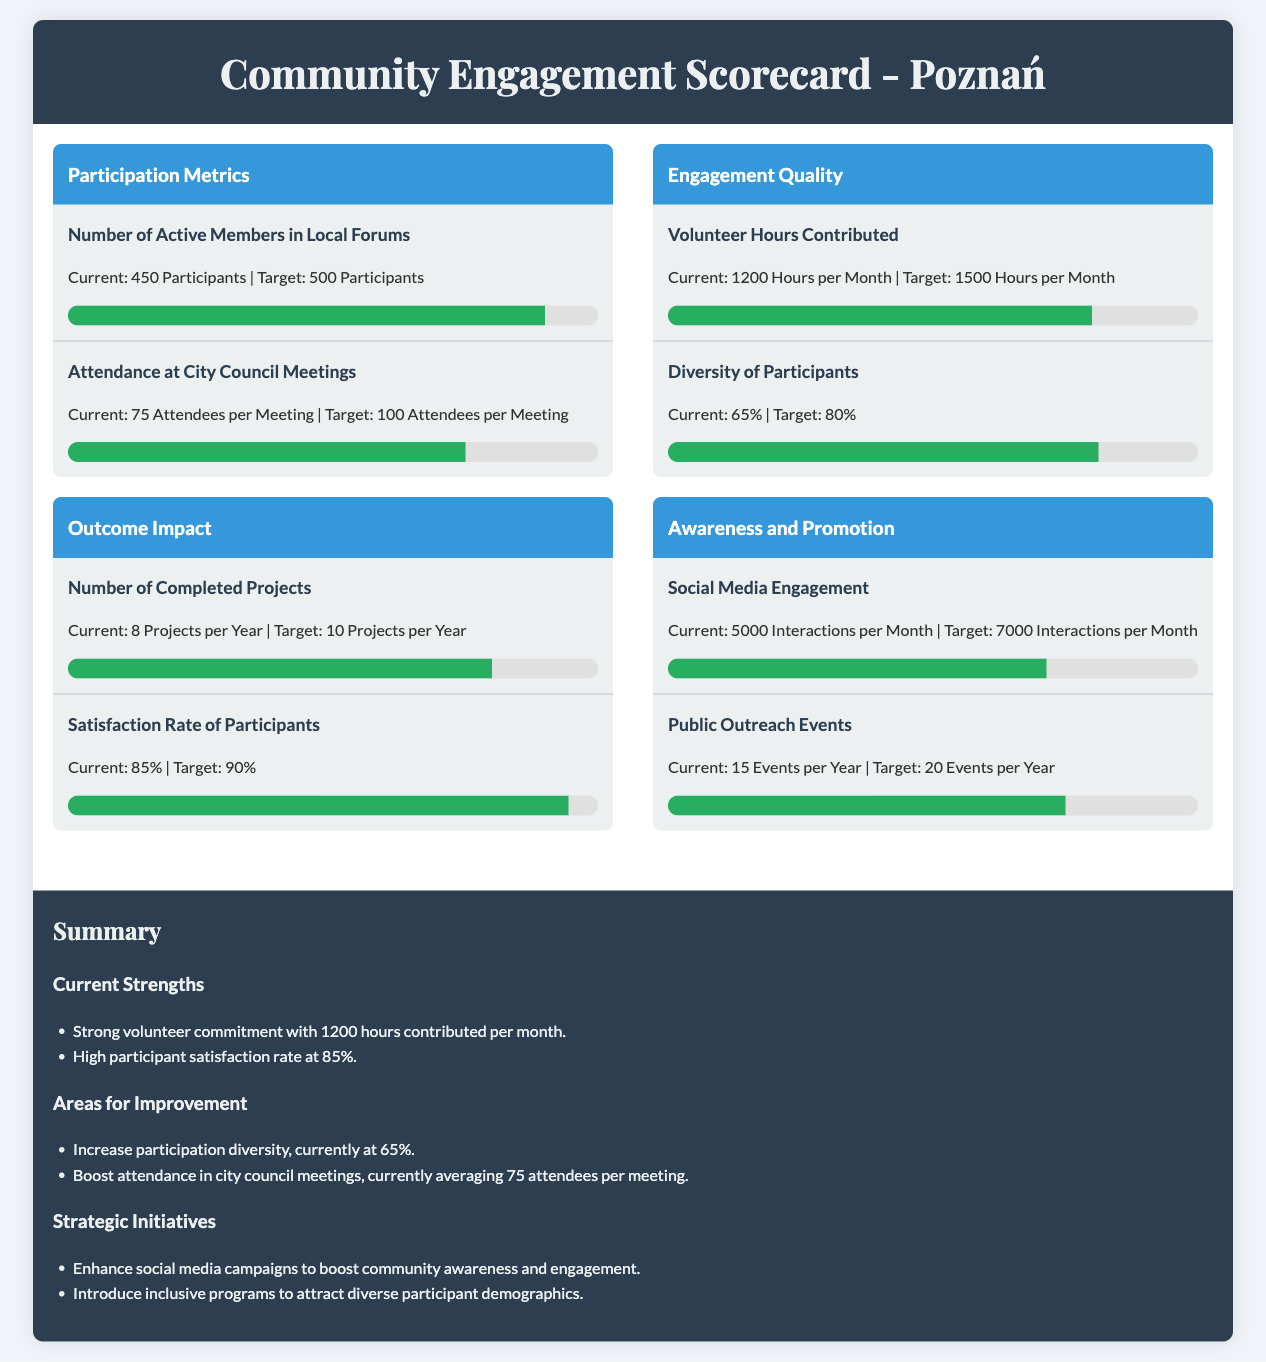What is the current number of active members in local forums? The current number of active members in local forums is explicitly stated in the document's metrics.
Answer: 450 Participants What is the target attendance for city council meetings? The target attendance for city council meetings is provided in the participation metrics section.
Answer: 100 Attendees per Meeting What is the current satisfaction rate of participants? The current satisfaction rate of participants is listed under the outcome impact category.
Answer: 85% How many social media interactions are currently taking place per month? The number of social media interactions is found in the awareness and promotion section of the scorecard.
Answer: 5000 Interactions per Month What is the progress towards the target for diversity of participants? The progress towards the target for diversity of participants is described in the engagement quality section, showing the current percentage and target.
Answer: 65% How many projects are completed per year currently? The number of completed projects per year is mentioned in the outcome impact category.
Answer: 8 Projects per Year What is the percentage of volunteer hours contributed towards the target? The percentage of volunteer hours contributed can be deduced from the current and target numbers provided in the metrics.
Answer: 80% What initiative is suggested to attract diverse participant demographics? The suggested strategic initiative to attract diverse participant demographics is mentioned in the strategic initiatives section.
Answer: Introduce inclusive programs What is the total number of public outreach events held per year? The total number of public outreach events per year is stated under the awareness and promotion section.
Answer: 15 Events per Year 